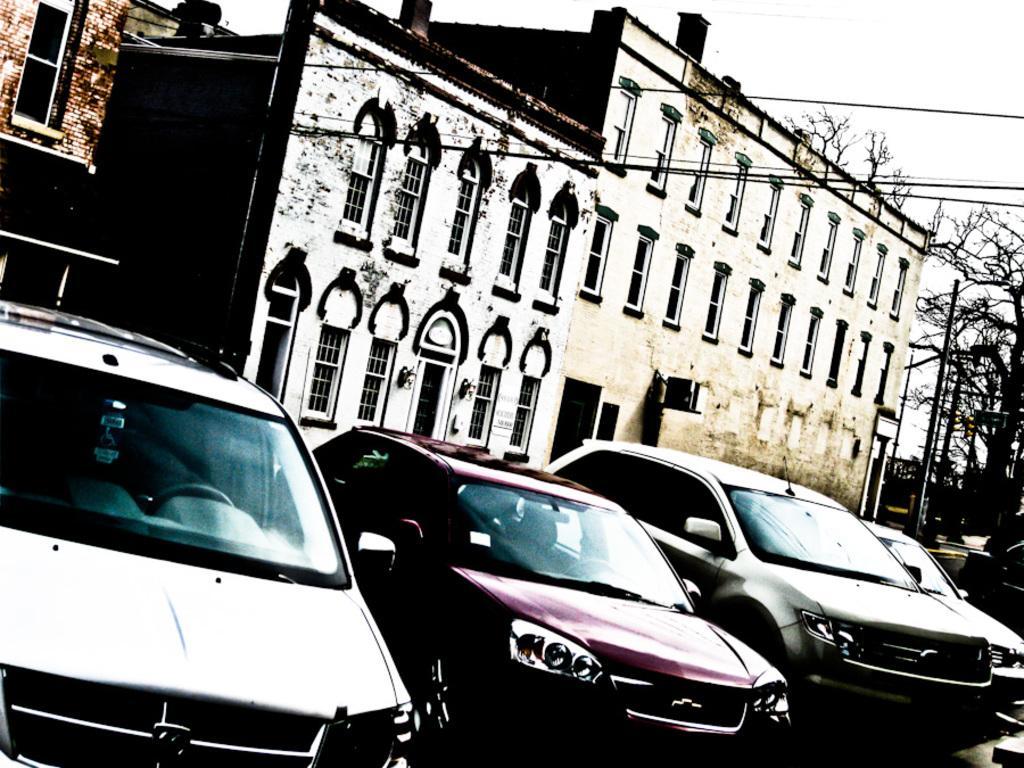Please provide a concise description of this image. In this image we can see buildings, cables, street poles, motor vehicles on the road, trees and sky. 